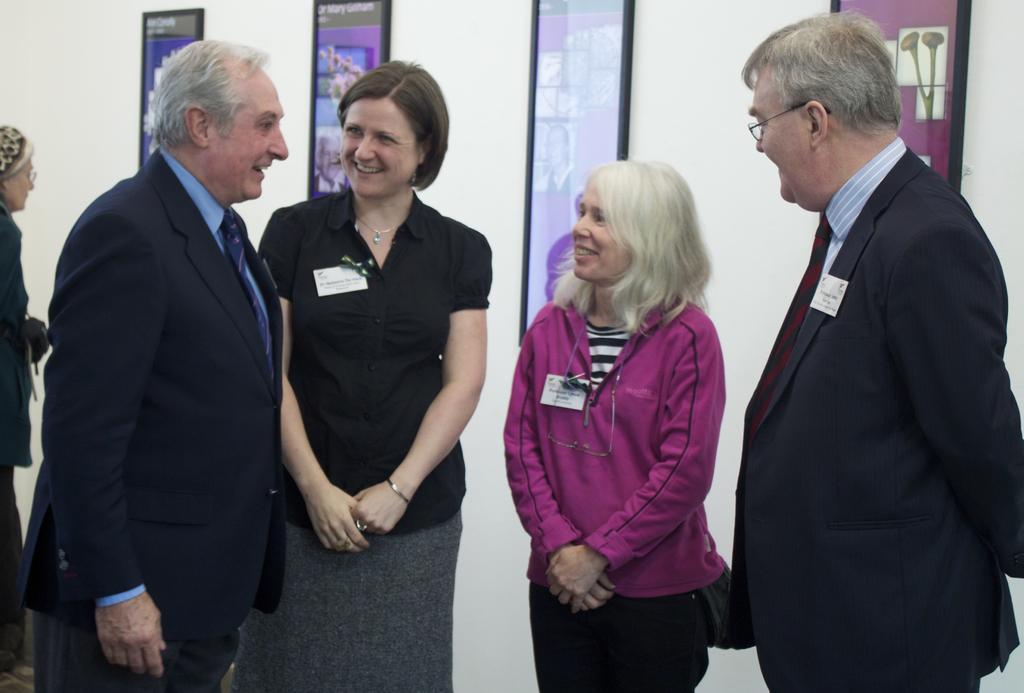How would you summarize this image in a sentence or two? In the center of the image we can see four persons are standing and they are in different costumes and we can see they are smiling. On the left side of the image, we can see a person. In the background there is a wall and frames. 